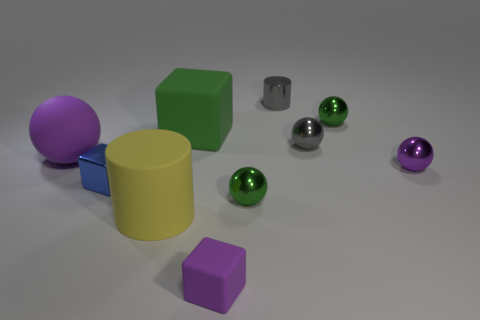Do the large green matte object and the tiny green metallic thing in front of the big purple object have the same shape?
Make the answer very short. No. Are there any large cubes that have the same color as the tiny metal cylinder?
Your answer should be very brief. No. How many cylinders are either small purple metallic things or gray shiny objects?
Offer a very short reply. 1. Is there a purple metallic thing that has the same shape as the yellow rubber object?
Your answer should be compact. No. What number of other objects are the same color as the tiny metal cylinder?
Your answer should be compact. 1. Is the number of blue metallic blocks that are behind the large cube less than the number of purple metal objects?
Give a very brief answer. Yes. What number of balls are there?
Provide a short and direct response. 5. How many blue cubes have the same material as the large cylinder?
Your answer should be compact. 0. What number of things are either small shiny objects to the right of the yellow thing or tiny cylinders?
Give a very brief answer. 5. Is the number of small purple rubber cubes that are behind the rubber cylinder less than the number of small gray spheres behind the tiny gray cylinder?
Give a very brief answer. No. 